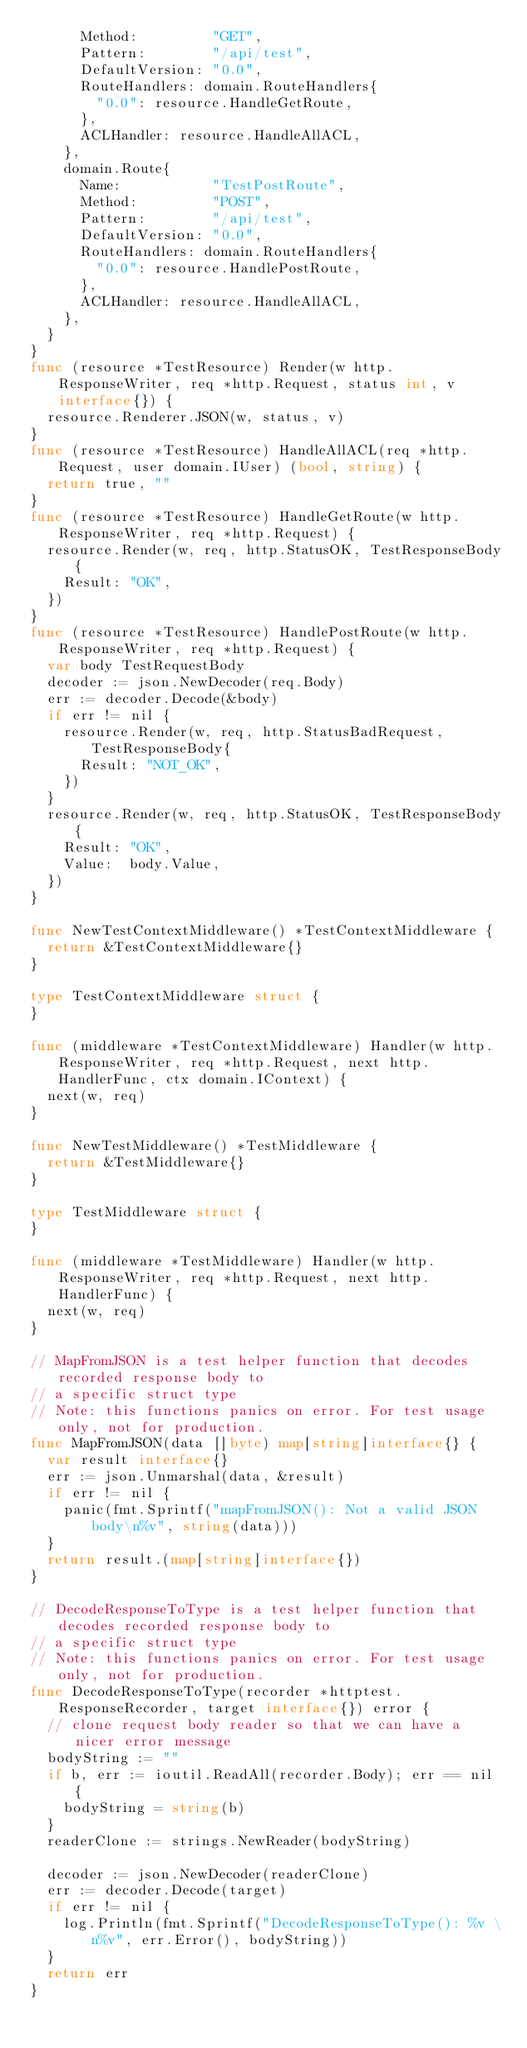<code> <loc_0><loc_0><loc_500><loc_500><_Go_>			Method:         "GET",
			Pattern:        "/api/test",
			DefaultVersion: "0.0",
			RouteHandlers: domain.RouteHandlers{
				"0.0": resource.HandleGetRoute,
			},
			ACLHandler: resource.HandleAllACL,
		},
		domain.Route{
			Name:           "TestPostRoute",
			Method:         "POST",
			Pattern:        "/api/test",
			DefaultVersion: "0.0",
			RouteHandlers: domain.RouteHandlers{
				"0.0": resource.HandlePostRoute,
			},
			ACLHandler: resource.HandleAllACL,
		},
	}
}
func (resource *TestResource) Render(w http.ResponseWriter, req *http.Request, status int, v interface{}) {
	resource.Renderer.JSON(w, status, v)
}
func (resource *TestResource) HandleAllACL(req *http.Request, user domain.IUser) (bool, string) {
	return true, ""
}
func (resource *TestResource) HandleGetRoute(w http.ResponseWriter, req *http.Request) {
	resource.Render(w, req, http.StatusOK, TestResponseBody{
		Result: "OK",
	})
}
func (resource *TestResource) HandlePostRoute(w http.ResponseWriter, req *http.Request) {
	var body TestRequestBody
	decoder := json.NewDecoder(req.Body)
	err := decoder.Decode(&body)
	if err != nil {
		resource.Render(w, req, http.StatusBadRequest, TestResponseBody{
			Result: "NOT_OK",
		})
	}
	resource.Render(w, req, http.StatusOK, TestResponseBody{
		Result: "OK",
		Value:  body.Value,
	})
}

func NewTestContextMiddleware() *TestContextMiddleware {
	return &TestContextMiddleware{}
}

type TestContextMiddleware struct {
}

func (middleware *TestContextMiddleware) Handler(w http.ResponseWriter, req *http.Request, next http.HandlerFunc, ctx domain.IContext) {
	next(w, req)
}

func NewTestMiddleware() *TestMiddleware {
	return &TestMiddleware{}
}

type TestMiddleware struct {
}

func (middleware *TestMiddleware) Handler(w http.ResponseWriter, req *http.Request, next http.HandlerFunc) {
	next(w, req)
}

// MapFromJSON is a test helper function that decodes recorded response body to
// a specific struct type
// Note: this functions panics on error. For test usage only, not for production.
func MapFromJSON(data []byte) map[string]interface{} {
	var result interface{}
	err := json.Unmarshal(data, &result)
	if err != nil {
		panic(fmt.Sprintf("mapFromJSON(): Not a valid JSON body\n%v", string(data)))
	}
	return result.(map[string]interface{})
}

// DecodeResponseToType is a test helper function that decodes recorded response body to
// a specific struct type
// Note: this functions panics on error. For test usage only, not for production.
func DecodeResponseToType(recorder *httptest.ResponseRecorder, target interface{}) error {
	// clone request body reader so that we can have a nicer error message
	bodyString := ""
	if b, err := ioutil.ReadAll(recorder.Body); err == nil {
		bodyString = string(b)
	}
	readerClone := strings.NewReader(bodyString)

	decoder := json.NewDecoder(readerClone)
	err := decoder.Decode(target)
	if err != nil {
		log.Println(fmt.Sprintf("DecodeResponseToType(): %v \n%v", err.Error(), bodyString))
	}
	return err
}
</code> 